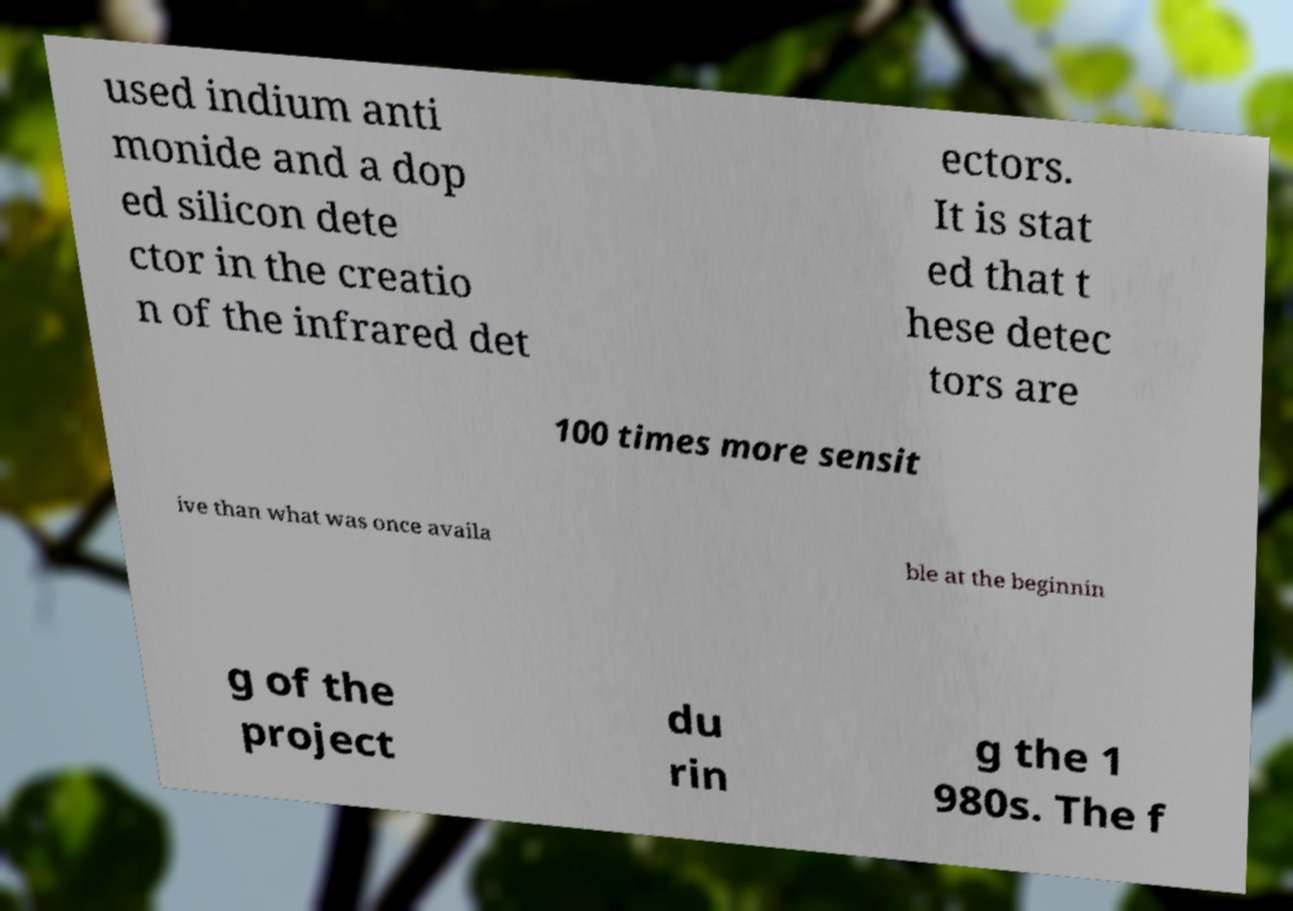There's text embedded in this image that I need extracted. Can you transcribe it verbatim? used indium anti monide and a dop ed silicon dete ctor in the creatio n of the infrared det ectors. It is stat ed that t hese detec tors are 100 times more sensit ive than what was once availa ble at the beginnin g of the project du rin g the 1 980s. The f 